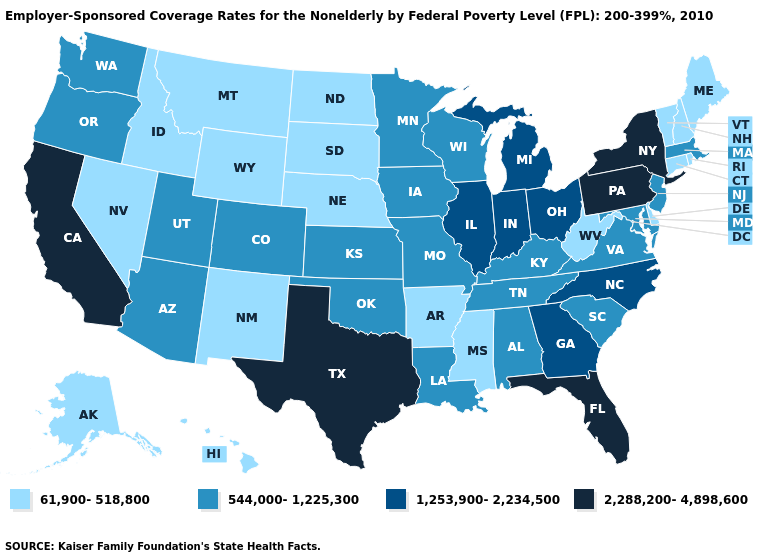How many symbols are there in the legend?
Write a very short answer. 4. Among the states that border Wyoming , which have the highest value?
Keep it brief. Colorado, Utah. Which states have the lowest value in the Northeast?
Answer briefly. Connecticut, Maine, New Hampshire, Rhode Island, Vermont. What is the highest value in the USA?
Keep it brief. 2,288,200-4,898,600. What is the lowest value in the West?
Short answer required. 61,900-518,800. What is the value of New Hampshire?
Give a very brief answer. 61,900-518,800. Does the first symbol in the legend represent the smallest category?
Give a very brief answer. Yes. Name the states that have a value in the range 544,000-1,225,300?
Write a very short answer. Alabama, Arizona, Colorado, Iowa, Kansas, Kentucky, Louisiana, Maryland, Massachusetts, Minnesota, Missouri, New Jersey, Oklahoma, Oregon, South Carolina, Tennessee, Utah, Virginia, Washington, Wisconsin. Name the states that have a value in the range 61,900-518,800?
Concise answer only. Alaska, Arkansas, Connecticut, Delaware, Hawaii, Idaho, Maine, Mississippi, Montana, Nebraska, Nevada, New Hampshire, New Mexico, North Dakota, Rhode Island, South Dakota, Vermont, West Virginia, Wyoming. Among the states that border Delaware , which have the highest value?
Concise answer only. Pennsylvania. Does Illinois have a lower value than New York?
Keep it brief. Yes. What is the value of Texas?
Short answer required. 2,288,200-4,898,600. Which states have the lowest value in the USA?
Short answer required. Alaska, Arkansas, Connecticut, Delaware, Hawaii, Idaho, Maine, Mississippi, Montana, Nebraska, Nevada, New Hampshire, New Mexico, North Dakota, Rhode Island, South Dakota, Vermont, West Virginia, Wyoming. Which states hav the highest value in the South?
Short answer required. Florida, Texas. What is the highest value in states that border North Carolina?
Quick response, please. 1,253,900-2,234,500. 